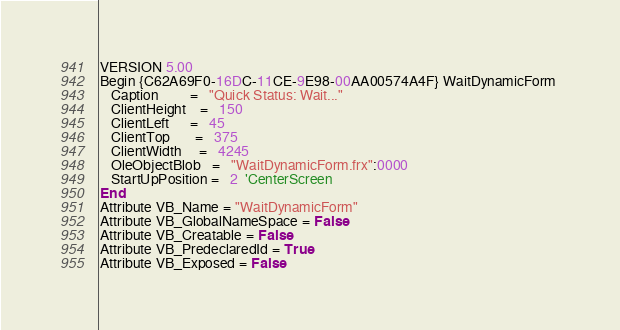Convert code to text. <code><loc_0><loc_0><loc_500><loc_500><_VisualBasic_>VERSION 5.00
Begin {C62A69F0-16DC-11CE-9E98-00AA00574A4F} WaitDynamicForm 
   Caption         =   "Quick Status: Wait..."
   ClientHeight    =   150
   ClientLeft      =   45
   ClientTop       =   375
   ClientWidth     =   4245
   OleObjectBlob   =   "WaitDynamicForm.frx":0000
   StartUpPosition =   2  'CenterScreen
End
Attribute VB_Name = "WaitDynamicForm"
Attribute VB_GlobalNameSpace = False
Attribute VB_Creatable = False
Attribute VB_PredeclaredId = True
Attribute VB_Exposed = False

</code> 